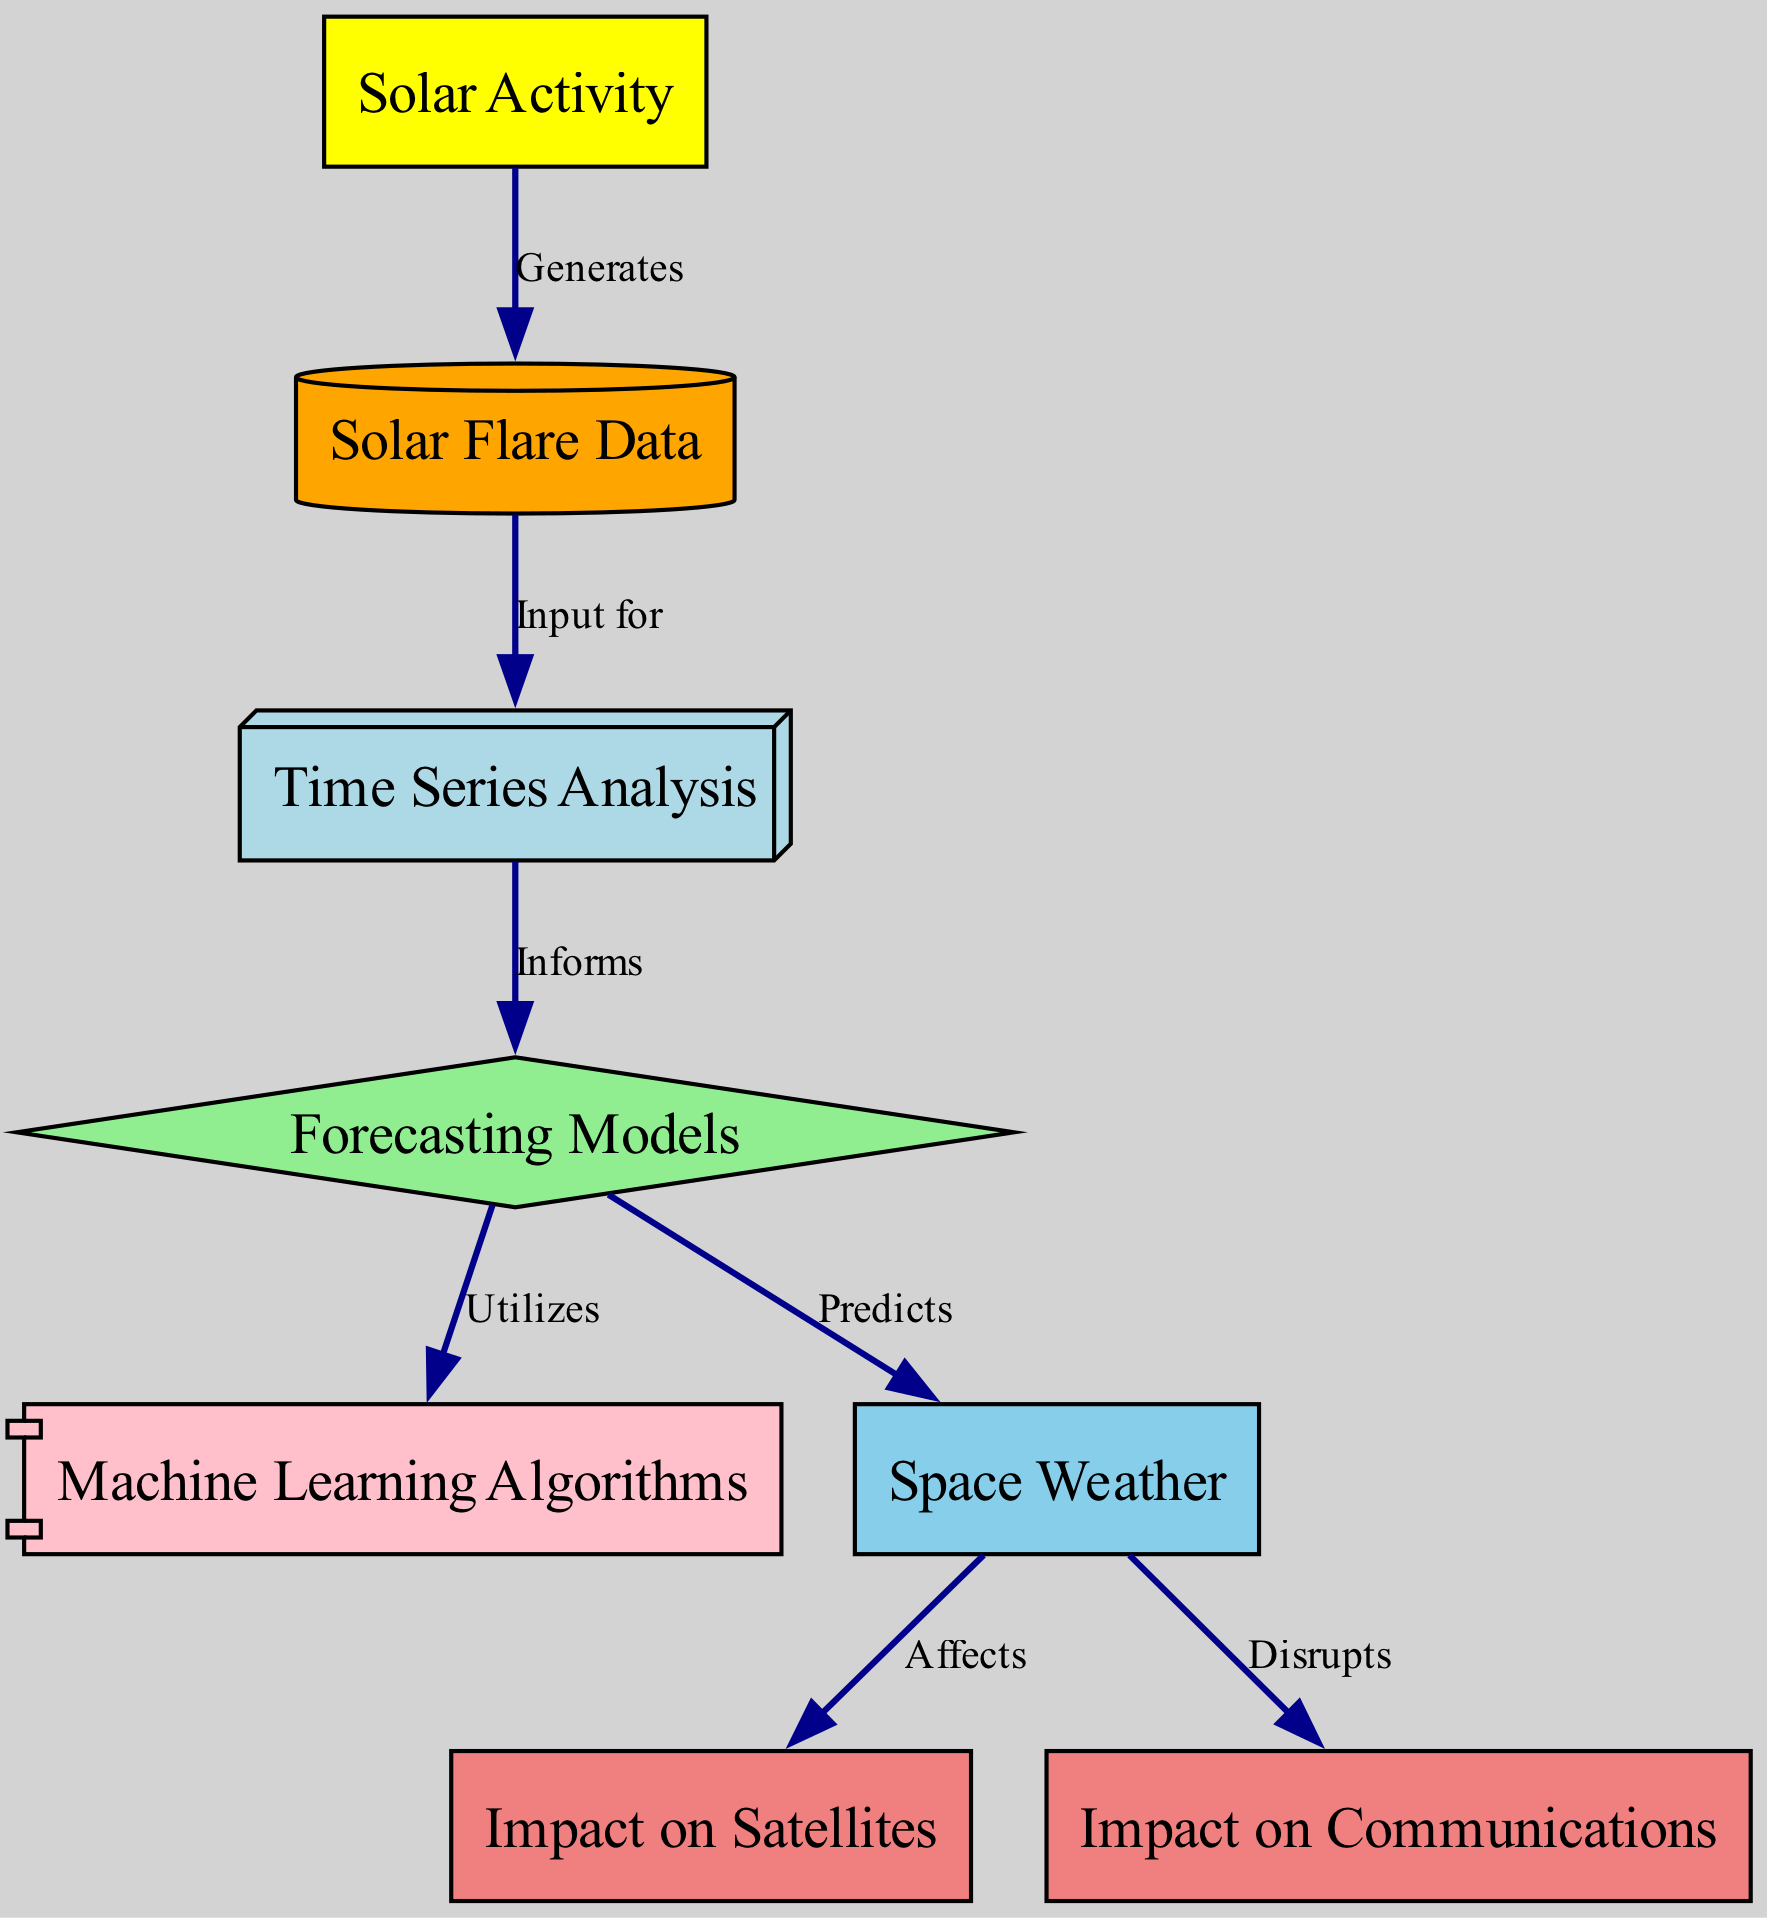What is the central topic of the diagram? The central topic is represented by the node labeled "Solar Activity," which serves as the starting point of the diagram and is the main focus of the visual representation.
Answer: Solar Activity How many nodes are present in the diagram? By counting the distinct nodes listed in the data, there are eight nodes illustrated, namely solar activity, solar flare data, time series analysis, forecasting models, machine learning algorithms, space weather, impact on satellites, and impact on communications.
Answer: 8 What does the "Solar Activity" generate? According to the edge relationship indicated in the diagram, "Solar Activity" generates "Solar Flare Data," as shown by the directed arrow from one to the other.
Answer: Solar Flare Data What does the "Time Series Analysis" inform? The arrow from "Time Series Analysis" to "Forecasting Models" indicates that time series analysis informs forecasting models, highlighting its role in the predictive process.
Answer: Forecasting Models Which node predicts space weather? The node labeled "Forecasting Models" directly predicts "Space Weather," as indicated by the directional edge connecting the two nodes.
Answer: Forecasting Models How does "Space Weather" affect satellites? The relationship between "Space Weather" and "Impact on Satellites" is outlined by the edge showing that space weather affects satellites, illustrating the implication of space weather changes.
Answer: Affects What is the relationship between "Space Weather" and communications? The diagram indicates that "Space Weather" disrupts "Impact on Communications," conveying the negative impact of space weather events on communication systems.
Answer: Disrupts What is the role of machine learning algorithms in the diagram? The node "Machine Learning Algorithms" is utilized by the "Forecasting Models," showing their importance as tools in the modeling process to enhance predictive accuracy.
Answer: Utilizes 